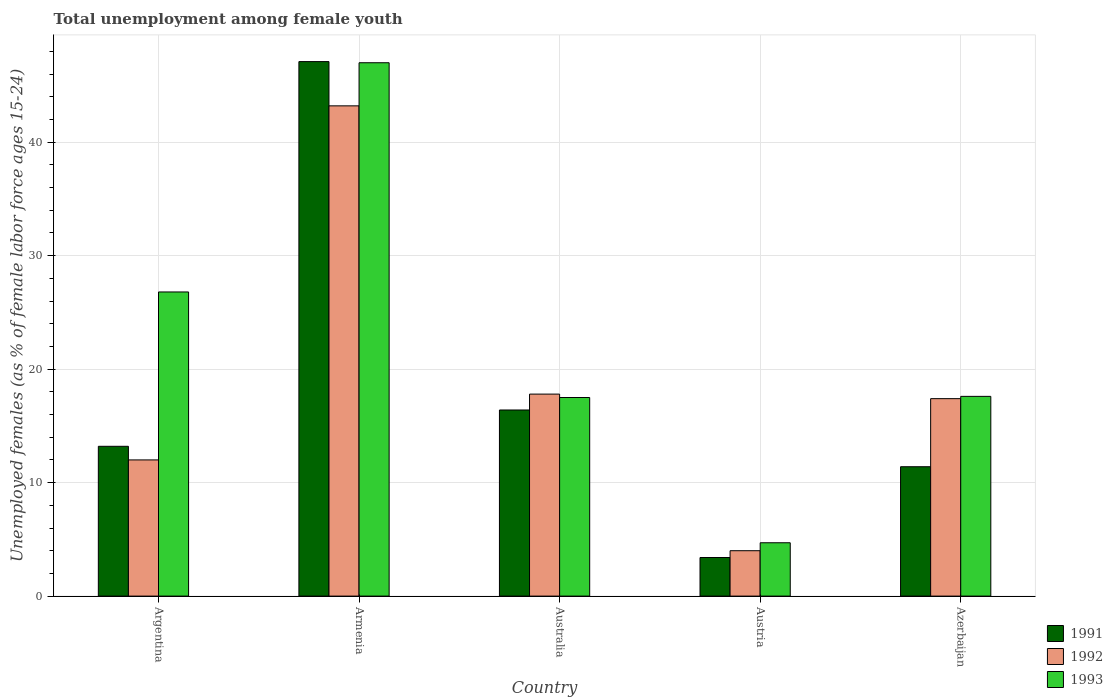How many different coloured bars are there?
Your answer should be very brief. 3. Are the number of bars per tick equal to the number of legend labels?
Keep it short and to the point. Yes. Are the number of bars on each tick of the X-axis equal?
Keep it short and to the point. Yes. How many bars are there on the 4th tick from the left?
Provide a short and direct response. 3. What is the label of the 2nd group of bars from the left?
Ensure brevity in your answer.  Armenia. In how many cases, is the number of bars for a given country not equal to the number of legend labels?
Offer a terse response. 0. What is the percentage of unemployed females in in 1993 in Azerbaijan?
Offer a very short reply. 17.6. Across all countries, what is the maximum percentage of unemployed females in in 1993?
Provide a short and direct response. 47. Across all countries, what is the minimum percentage of unemployed females in in 1992?
Provide a short and direct response. 4. In which country was the percentage of unemployed females in in 1993 maximum?
Your answer should be very brief. Armenia. In which country was the percentage of unemployed females in in 1992 minimum?
Offer a very short reply. Austria. What is the total percentage of unemployed females in in 1993 in the graph?
Offer a very short reply. 113.6. What is the difference between the percentage of unemployed females in in 1992 in Armenia and that in Azerbaijan?
Offer a very short reply. 25.8. What is the difference between the percentage of unemployed females in in 1993 in Armenia and the percentage of unemployed females in in 1991 in Australia?
Your answer should be compact. 30.6. What is the average percentage of unemployed females in in 1992 per country?
Your answer should be compact. 18.88. What is the difference between the percentage of unemployed females in of/in 1992 and percentage of unemployed females in of/in 1993 in Azerbaijan?
Offer a terse response. -0.2. In how many countries, is the percentage of unemployed females in in 1993 greater than 42 %?
Offer a terse response. 1. What is the ratio of the percentage of unemployed females in in 1991 in Armenia to that in Austria?
Offer a very short reply. 13.85. Is the percentage of unemployed females in in 1991 in Armenia less than that in Austria?
Provide a short and direct response. No. What is the difference between the highest and the second highest percentage of unemployed females in in 1993?
Keep it short and to the point. -9.2. What is the difference between the highest and the lowest percentage of unemployed females in in 1991?
Your answer should be compact. 43.7. Is the sum of the percentage of unemployed females in in 1991 in Armenia and Austria greater than the maximum percentage of unemployed females in in 1993 across all countries?
Your answer should be compact. Yes. Is it the case that in every country, the sum of the percentage of unemployed females in in 1991 and percentage of unemployed females in in 1993 is greater than the percentage of unemployed females in in 1992?
Your answer should be compact. Yes. Are the values on the major ticks of Y-axis written in scientific E-notation?
Ensure brevity in your answer.  No. Where does the legend appear in the graph?
Your answer should be compact. Bottom right. How are the legend labels stacked?
Make the answer very short. Vertical. What is the title of the graph?
Provide a short and direct response. Total unemployment among female youth. What is the label or title of the X-axis?
Keep it short and to the point. Country. What is the label or title of the Y-axis?
Offer a terse response. Unemployed females (as % of female labor force ages 15-24). What is the Unemployed females (as % of female labor force ages 15-24) in 1991 in Argentina?
Ensure brevity in your answer.  13.2. What is the Unemployed females (as % of female labor force ages 15-24) in 1993 in Argentina?
Your answer should be compact. 26.8. What is the Unemployed females (as % of female labor force ages 15-24) in 1991 in Armenia?
Offer a terse response. 47.1. What is the Unemployed females (as % of female labor force ages 15-24) in 1992 in Armenia?
Make the answer very short. 43.2. What is the Unemployed females (as % of female labor force ages 15-24) of 1993 in Armenia?
Your answer should be compact. 47. What is the Unemployed females (as % of female labor force ages 15-24) in 1991 in Australia?
Make the answer very short. 16.4. What is the Unemployed females (as % of female labor force ages 15-24) in 1992 in Australia?
Offer a very short reply. 17.8. What is the Unemployed females (as % of female labor force ages 15-24) in 1991 in Austria?
Provide a short and direct response. 3.4. What is the Unemployed females (as % of female labor force ages 15-24) of 1992 in Austria?
Give a very brief answer. 4. What is the Unemployed females (as % of female labor force ages 15-24) in 1993 in Austria?
Your answer should be very brief. 4.7. What is the Unemployed females (as % of female labor force ages 15-24) in 1991 in Azerbaijan?
Ensure brevity in your answer.  11.4. What is the Unemployed females (as % of female labor force ages 15-24) in 1992 in Azerbaijan?
Make the answer very short. 17.4. What is the Unemployed females (as % of female labor force ages 15-24) of 1993 in Azerbaijan?
Keep it short and to the point. 17.6. Across all countries, what is the maximum Unemployed females (as % of female labor force ages 15-24) in 1991?
Give a very brief answer. 47.1. Across all countries, what is the maximum Unemployed females (as % of female labor force ages 15-24) of 1992?
Keep it short and to the point. 43.2. Across all countries, what is the minimum Unemployed females (as % of female labor force ages 15-24) of 1991?
Keep it short and to the point. 3.4. Across all countries, what is the minimum Unemployed females (as % of female labor force ages 15-24) of 1992?
Provide a short and direct response. 4. Across all countries, what is the minimum Unemployed females (as % of female labor force ages 15-24) of 1993?
Make the answer very short. 4.7. What is the total Unemployed females (as % of female labor force ages 15-24) of 1991 in the graph?
Offer a very short reply. 91.5. What is the total Unemployed females (as % of female labor force ages 15-24) of 1992 in the graph?
Ensure brevity in your answer.  94.4. What is the total Unemployed females (as % of female labor force ages 15-24) of 1993 in the graph?
Ensure brevity in your answer.  113.6. What is the difference between the Unemployed females (as % of female labor force ages 15-24) of 1991 in Argentina and that in Armenia?
Your answer should be compact. -33.9. What is the difference between the Unemployed females (as % of female labor force ages 15-24) of 1992 in Argentina and that in Armenia?
Ensure brevity in your answer.  -31.2. What is the difference between the Unemployed females (as % of female labor force ages 15-24) in 1993 in Argentina and that in Armenia?
Offer a very short reply. -20.2. What is the difference between the Unemployed females (as % of female labor force ages 15-24) in 1991 in Argentina and that in Australia?
Provide a short and direct response. -3.2. What is the difference between the Unemployed females (as % of female labor force ages 15-24) in 1992 in Argentina and that in Australia?
Offer a terse response. -5.8. What is the difference between the Unemployed females (as % of female labor force ages 15-24) in 1993 in Argentina and that in Australia?
Provide a succinct answer. 9.3. What is the difference between the Unemployed females (as % of female labor force ages 15-24) in 1991 in Argentina and that in Austria?
Offer a very short reply. 9.8. What is the difference between the Unemployed females (as % of female labor force ages 15-24) of 1993 in Argentina and that in Austria?
Your response must be concise. 22.1. What is the difference between the Unemployed females (as % of female labor force ages 15-24) in 1992 in Argentina and that in Azerbaijan?
Offer a very short reply. -5.4. What is the difference between the Unemployed females (as % of female labor force ages 15-24) of 1991 in Armenia and that in Australia?
Keep it short and to the point. 30.7. What is the difference between the Unemployed females (as % of female labor force ages 15-24) in 1992 in Armenia and that in Australia?
Ensure brevity in your answer.  25.4. What is the difference between the Unemployed females (as % of female labor force ages 15-24) in 1993 in Armenia and that in Australia?
Provide a succinct answer. 29.5. What is the difference between the Unemployed females (as % of female labor force ages 15-24) in 1991 in Armenia and that in Austria?
Ensure brevity in your answer.  43.7. What is the difference between the Unemployed females (as % of female labor force ages 15-24) in 1992 in Armenia and that in Austria?
Provide a succinct answer. 39.2. What is the difference between the Unemployed females (as % of female labor force ages 15-24) in 1993 in Armenia and that in Austria?
Make the answer very short. 42.3. What is the difference between the Unemployed females (as % of female labor force ages 15-24) in 1991 in Armenia and that in Azerbaijan?
Offer a very short reply. 35.7. What is the difference between the Unemployed females (as % of female labor force ages 15-24) in 1992 in Armenia and that in Azerbaijan?
Give a very brief answer. 25.8. What is the difference between the Unemployed females (as % of female labor force ages 15-24) in 1993 in Armenia and that in Azerbaijan?
Ensure brevity in your answer.  29.4. What is the difference between the Unemployed females (as % of female labor force ages 15-24) of 1993 in Australia and that in Austria?
Your answer should be compact. 12.8. What is the difference between the Unemployed females (as % of female labor force ages 15-24) of 1993 in Australia and that in Azerbaijan?
Provide a succinct answer. -0.1. What is the difference between the Unemployed females (as % of female labor force ages 15-24) of 1992 in Austria and that in Azerbaijan?
Offer a very short reply. -13.4. What is the difference between the Unemployed females (as % of female labor force ages 15-24) of 1991 in Argentina and the Unemployed females (as % of female labor force ages 15-24) of 1992 in Armenia?
Provide a succinct answer. -30. What is the difference between the Unemployed females (as % of female labor force ages 15-24) of 1991 in Argentina and the Unemployed females (as % of female labor force ages 15-24) of 1993 in Armenia?
Give a very brief answer. -33.8. What is the difference between the Unemployed females (as % of female labor force ages 15-24) of 1992 in Argentina and the Unemployed females (as % of female labor force ages 15-24) of 1993 in Armenia?
Provide a succinct answer. -35. What is the difference between the Unemployed females (as % of female labor force ages 15-24) in 1991 in Argentina and the Unemployed females (as % of female labor force ages 15-24) in 1993 in Australia?
Your response must be concise. -4.3. What is the difference between the Unemployed females (as % of female labor force ages 15-24) of 1991 in Argentina and the Unemployed females (as % of female labor force ages 15-24) of 1993 in Austria?
Your response must be concise. 8.5. What is the difference between the Unemployed females (as % of female labor force ages 15-24) of 1991 in Argentina and the Unemployed females (as % of female labor force ages 15-24) of 1993 in Azerbaijan?
Make the answer very short. -4.4. What is the difference between the Unemployed females (as % of female labor force ages 15-24) in 1992 in Argentina and the Unemployed females (as % of female labor force ages 15-24) in 1993 in Azerbaijan?
Give a very brief answer. -5.6. What is the difference between the Unemployed females (as % of female labor force ages 15-24) in 1991 in Armenia and the Unemployed females (as % of female labor force ages 15-24) in 1992 in Australia?
Provide a succinct answer. 29.3. What is the difference between the Unemployed females (as % of female labor force ages 15-24) of 1991 in Armenia and the Unemployed females (as % of female labor force ages 15-24) of 1993 in Australia?
Ensure brevity in your answer.  29.6. What is the difference between the Unemployed females (as % of female labor force ages 15-24) in 1992 in Armenia and the Unemployed females (as % of female labor force ages 15-24) in 1993 in Australia?
Your answer should be compact. 25.7. What is the difference between the Unemployed females (as % of female labor force ages 15-24) in 1991 in Armenia and the Unemployed females (as % of female labor force ages 15-24) in 1992 in Austria?
Ensure brevity in your answer.  43.1. What is the difference between the Unemployed females (as % of female labor force ages 15-24) of 1991 in Armenia and the Unemployed females (as % of female labor force ages 15-24) of 1993 in Austria?
Your answer should be very brief. 42.4. What is the difference between the Unemployed females (as % of female labor force ages 15-24) in 1992 in Armenia and the Unemployed females (as % of female labor force ages 15-24) in 1993 in Austria?
Give a very brief answer. 38.5. What is the difference between the Unemployed females (as % of female labor force ages 15-24) in 1991 in Armenia and the Unemployed females (as % of female labor force ages 15-24) in 1992 in Azerbaijan?
Your answer should be compact. 29.7. What is the difference between the Unemployed females (as % of female labor force ages 15-24) in 1991 in Armenia and the Unemployed females (as % of female labor force ages 15-24) in 1993 in Azerbaijan?
Give a very brief answer. 29.5. What is the difference between the Unemployed females (as % of female labor force ages 15-24) in 1992 in Armenia and the Unemployed females (as % of female labor force ages 15-24) in 1993 in Azerbaijan?
Ensure brevity in your answer.  25.6. What is the difference between the Unemployed females (as % of female labor force ages 15-24) in 1991 in Australia and the Unemployed females (as % of female labor force ages 15-24) in 1992 in Austria?
Provide a succinct answer. 12.4. What is the difference between the Unemployed females (as % of female labor force ages 15-24) in 1992 in Australia and the Unemployed females (as % of female labor force ages 15-24) in 1993 in Azerbaijan?
Your answer should be very brief. 0.2. What is the difference between the Unemployed females (as % of female labor force ages 15-24) in 1991 in Austria and the Unemployed females (as % of female labor force ages 15-24) in 1993 in Azerbaijan?
Provide a succinct answer. -14.2. What is the difference between the Unemployed females (as % of female labor force ages 15-24) in 1992 in Austria and the Unemployed females (as % of female labor force ages 15-24) in 1993 in Azerbaijan?
Ensure brevity in your answer.  -13.6. What is the average Unemployed females (as % of female labor force ages 15-24) in 1991 per country?
Offer a very short reply. 18.3. What is the average Unemployed females (as % of female labor force ages 15-24) of 1992 per country?
Keep it short and to the point. 18.88. What is the average Unemployed females (as % of female labor force ages 15-24) in 1993 per country?
Keep it short and to the point. 22.72. What is the difference between the Unemployed females (as % of female labor force ages 15-24) of 1992 and Unemployed females (as % of female labor force ages 15-24) of 1993 in Argentina?
Provide a short and direct response. -14.8. What is the difference between the Unemployed females (as % of female labor force ages 15-24) in 1991 and Unemployed females (as % of female labor force ages 15-24) in 1992 in Armenia?
Give a very brief answer. 3.9. What is the difference between the Unemployed females (as % of female labor force ages 15-24) of 1991 and Unemployed females (as % of female labor force ages 15-24) of 1993 in Armenia?
Offer a very short reply. 0.1. What is the difference between the Unemployed females (as % of female labor force ages 15-24) in 1991 and Unemployed females (as % of female labor force ages 15-24) in 1992 in Australia?
Your answer should be very brief. -1.4. What is the difference between the Unemployed females (as % of female labor force ages 15-24) in 1991 and Unemployed females (as % of female labor force ages 15-24) in 1993 in Australia?
Your response must be concise. -1.1. What is the difference between the Unemployed females (as % of female labor force ages 15-24) of 1991 and Unemployed females (as % of female labor force ages 15-24) of 1992 in Austria?
Provide a short and direct response. -0.6. What is the difference between the Unemployed females (as % of female labor force ages 15-24) of 1992 and Unemployed females (as % of female labor force ages 15-24) of 1993 in Austria?
Your answer should be compact. -0.7. What is the difference between the Unemployed females (as % of female labor force ages 15-24) in 1991 and Unemployed females (as % of female labor force ages 15-24) in 1992 in Azerbaijan?
Provide a short and direct response. -6. What is the difference between the Unemployed females (as % of female labor force ages 15-24) of 1991 and Unemployed females (as % of female labor force ages 15-24) of 1993 in Azerbaijan?
Ensure brevity in your answer.  -6.2. What is the difference between the Unemployed females (as % of female labor force ages 15-24) of 1992 and Unemployed females (as % of female labor force ages 15-24) of 1993 in Azerbaijan?
Keep it short and to the point. -0.2. What is the ratio of the Unemployed females (as % of female labor force ages 15-24) in 1991 in Argentina to that in Armenia?
Your response must be concise. 0.28. What is the ratio of the Unemployed females (as % of female labor force ages 15-24) in 1992 in Argentina to that in Armenia?
Offer a terse response. 0.28. What is the ratio of the Unemployed females (as % of female labor force ages 15-24) in 1993 in Argentina to that in Armenia?
Offer a very short reply. 0.57. What is the ratio of the Unemployed females (as % of female labor force ages 15-24) in 1991 in Argentina to that in Australia?
Keep it short and to the point. 0.8. What is the ratio of the Unemployed females (as % of female labor force ages 15-24) in 1992 in Argentina to that in Australia?
Keep it short and to the point. 0.67. What is the ratio of the Unemployed females (as % of female labor force ages 15-24) of 1993 in Argentina to that in Australia?
Your answer should be compact. 1.53. What is the ratio of the Unemployed females (as % of female labor force ages 15-24) in 1991 in Argentina to that in Austria?
Your response must be concise. 3.88. What is the ratio of the Unemployed females (as % of female labor force ages 15-24) of 1993 in Argentina to that in Austria?
Provide a short and direct response. 5.7. What is the ratio of the Unemployed females (as % of female labor force ages 15-24) of 1991 in Argentina to that in Azerbaijan?
Your answer should be very brief. 1.16. What is the ratio of the Unemployed females (as % of female labor force ages 15-24) of 1992 in Argentina to that in Azerbaijan?
Your response must be concise. 0.69. What is the ratio of the Unemployed females (as % of female labor force ages 15-24) in 1993 in Argentina to that in Azerbaijan?
Your answer should be compact. 1.52. What is the ratio of the Unemployed females (as % of female labor force ages 15-24) of 1991 in Armenia to that in Australia?
Your answer should be compact. 2.87. What is the ratio of the Unemployed females (as % of female labor force ages 15-24) in 1992 in Armenia to that in Australia?
Ensure brevity in your answer.  2.43. What is the ratio of the Unemployed females (as % of female labor force ages 15-24) in 1993 in Armenia to that in Australia?
Make the answer very short. 2.69. What is the ratio of the Unemployed females (as % of female labor force ages 15-24) of 1991 in Armenia to that in Austria?
Provide a short and direct response. 13.85. What is the ratio of the Unemployed females (as % of female labor force ages 15-24) of 1993 in Armenia to that in Austria?
Your response must be concise. 10. What is the ratio of the Unemployed females (as % of female labor force ages 15-24) of 1991 in Armenia to that in Azerbaijan?
Your response must be concise. 4.13. What is the ratio of the Unemployed females (as % of female labor force ages 15-24) of 1992 in Armenia to that in Azerbaijan?
Provide a succinct answer. 2.48. What is the ratio of the Unemployed females (as % of female labor force ages 15-24) in 1993 in Armenia to that in Azerbaijan?
Offer a terse response. 2.67. What is the ratio of the Unemployed females (as % of female labor force ages 15-24) in 1991 in Australia to that in Austria?
Your response must be concise. 4.82. What is the ratio of the Unemployed females (as % of female labor force ages 15-24) in 1992 in Australia to that in Austria?
Your answer should be compact. 4.45. What is the ratio of the Unemployed females (as % of female labor force ages 15-24) in 1993 in Australia to that in Austria?
Provide a succinct answer. 3.72. What is the ratio of the Unemployed females (as % of female labor force ages 15-24) of 1991 in Australia to that in Azerbaijan?
Provide a short and direct response. 1.44. What is the ratio of the Unemployed females (as % of female labor force ages 15-24) of 1992 in Australia to that in Azerbaijan?
Give a very brief answer. 1.02. What is the ratio of the Unemployed females (as % of female labor force ages 15-24) in 1993 in Australia to that in Azerbaijan?
Keep it short and to the point. 0.99. What is the ratio of the Unemployed females (as % of female labor force ages 15-24) in 1991 in Austria to that in Azerbaijan?
Your answer should be compact. 0.3. What is the ratio of the Unemployed females (as % of female labor force ages 15-24) in 1992 in Austria to that in Azerbaijan?
Your answer should be very brief. 0.23. What is the ratio of the Unemployed females (as % of female labor force ages 15-24) of 1993 in Austria to that in Azerbaijan?
Keep it short and to the point. 0.27. What is the difference between the highest and the second highest Unemployed females (as % of female labor force ages 15-24) in 1991?
Give a very brief answer. 30.7. What is the difference between the highest and the second highest Unemployed females (as % of female labor force ages 15-24) in 1992?
Your answer should be compact. 25.4. What is the difference between the highest and the second highest Unemployed females (as % of female labor force ages 15-24) of 1993?
Make the answer very short. 20.2. What is the difference between the highest and the lowest Unemployed females (as % of female labor force ages 15-24) in 1991?
Offer a terse response. 43.7. What is the difference between the highest and the lowest Unemployed females (as % of female labor force ages 15-24) in 1992?
Provide a succinct answer. 39.2. What is the difference between the highest and the lowest Unemployed females (as % of female labor force ages 15-24) in 1993?
Make the answer very short. 42.3. 